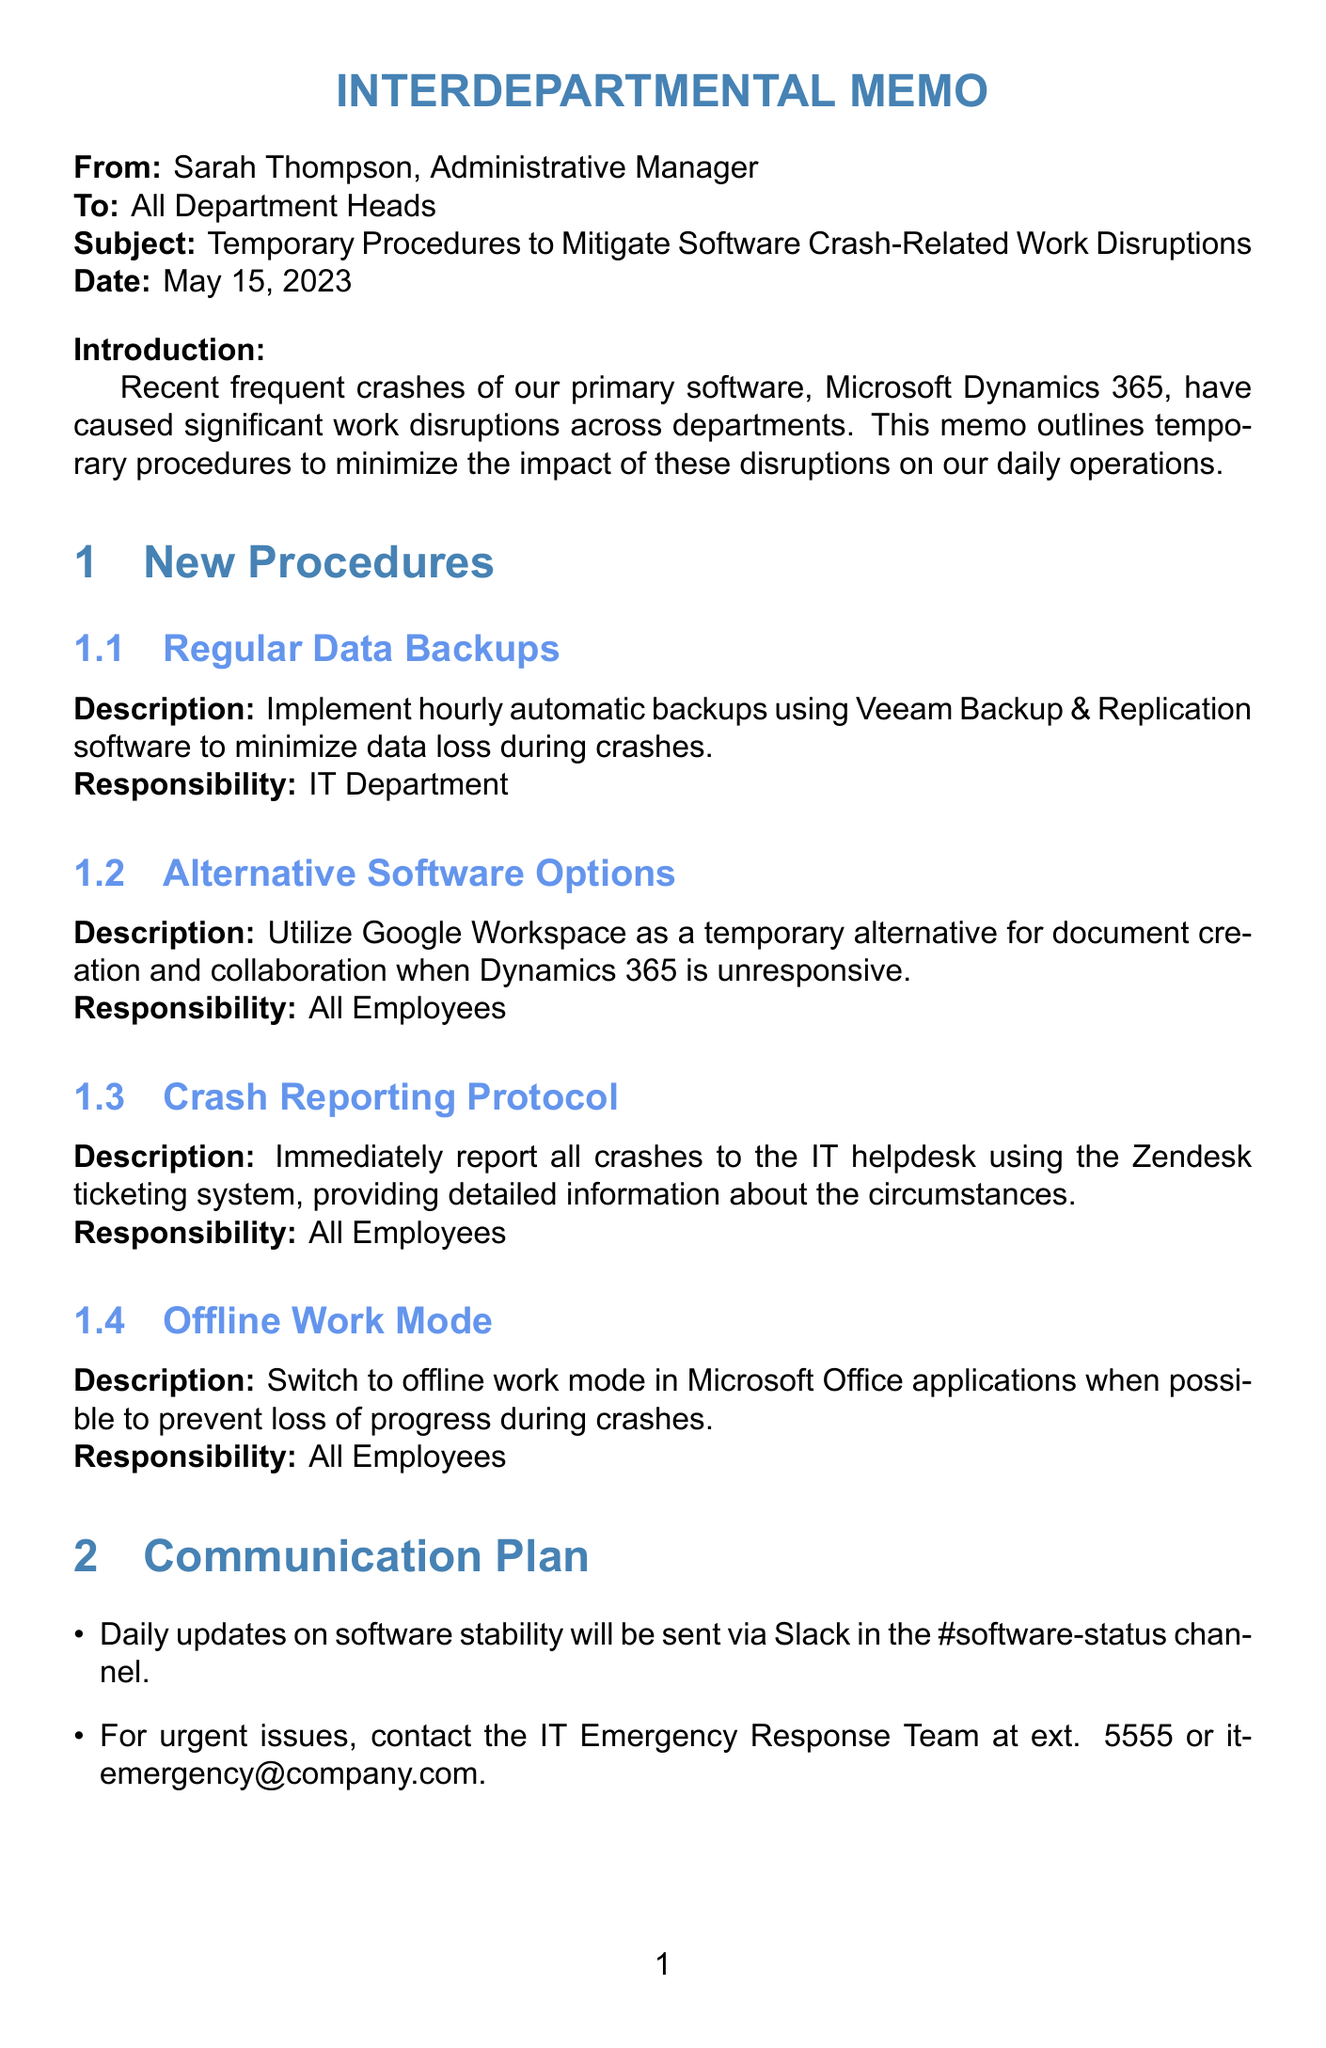what is the date of the memo? The date of the memo is explicitly mentioned in the header section as May 15, 2023.
Answer: May 15, 2023 who is the memo addressed to? The memo is addressed to "All Department Heads," which is specified in the header.
Answer: All Department Heads what software is primarily causing crashes? The document states that the primary software causing disruptions is Microsoft Dynamics 365.
Answer: Microsoft Dynamics 365 what is the responsibility for implementing regular data backups? The document specifies that the responsibility for implementing regular data backups falls to the IT Department.
Answer: IT Department how often should data backups be conducted? The procedure mentions that data backups should be implemented hourly, indicating the frequency required.
Answer: hourly what communication platform will provide daily updates? The memo states that updates on software stability will be sent via Slack, indicating the platform for communication.
Answer: Slack what is the purpose of the alternative software options? The purpose of using alternative software is to allow document creation and collaboration when Dynamics 365 is unresponsive.
Answer: document creation and collaboration how should employees report crashes? The memo outlines that employees should report crashes immediately to the IT helpdesk using the Zendesk ticketing system.
Answer: Zendesk ticketing system what are the hours for the virtual training sessions? The memo notes that virtual training sessions occur every Wednesday at 2 PM, indicating the timing for training.
Answer: every Wednesday at 2 PM 